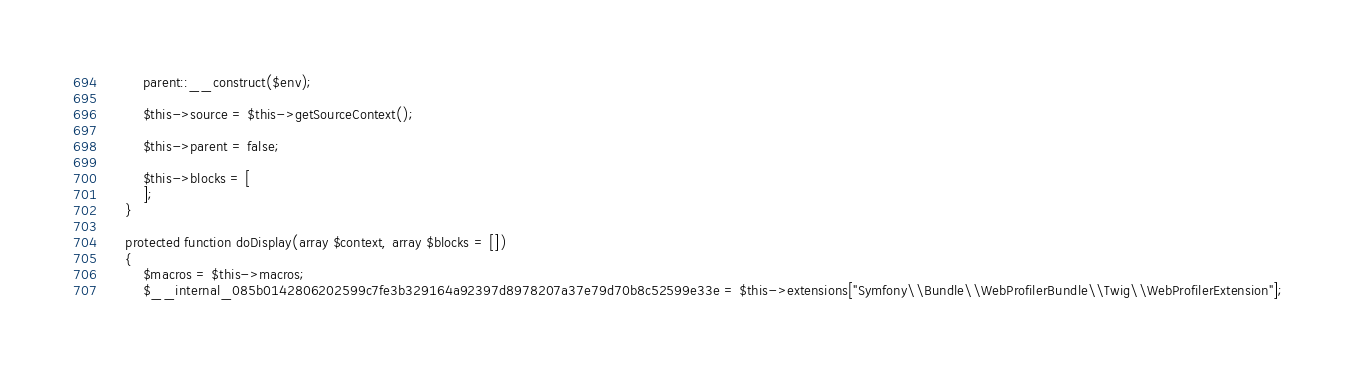<code> <loc_0><loc_0><loc_500><loc_500><_PHP_>        parent::__construct($env);

        $this->source = $this->getSourceContext();

        $this->parent = false;

        $this->blocks = [
        ];
    }

    protected function doDisplay(array $context, array $blocks = [])
    {
        $macros = $this->macros;
        $__internal_085b0142806202599c7fe3b329164a92397d8978207a37e79d70b8c52599e33e = $this->extensions["Symfony\\Bundle\\WebProfilerBundle\\Twig\\WebProfilerExtension"];</code> 